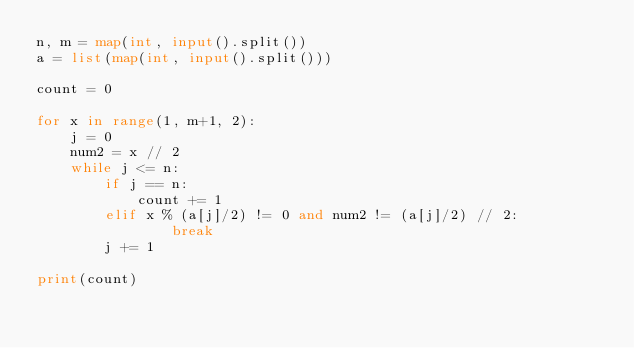<code> <loc_0><loc_0><loc_500><loc_500><_Python_>n, m = map(int, input().split())
a = list(map(int, input().split()))

count = 0

for x in range(1, m+1, 2):
    j = 0
    num2 = x // 2
    while j <= n:
        if j == n:
            count += 1
        elif x % (a[j]/2) != 0 and num2 != (a[j]/2) // 2:
                break
        j += 1

print(count)</code> 